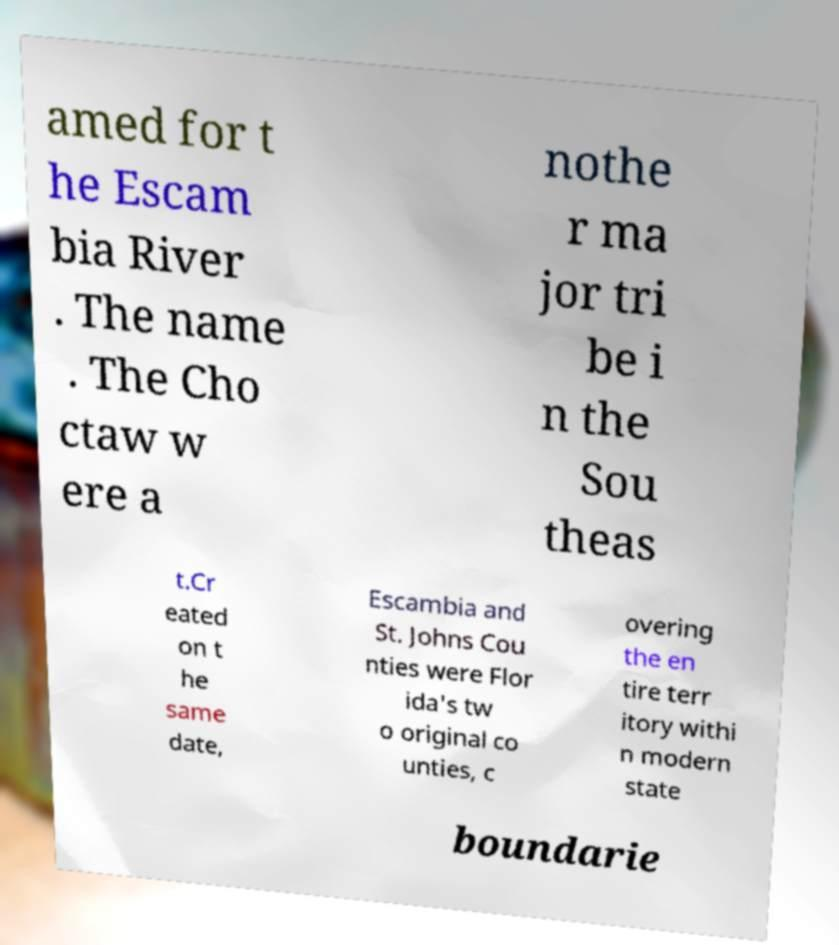Please read and relay the text visible in this image. What does it say? amed for t he Escam bia River . The name . The Cho ctaw w ere a nothe r ma jor tri be i n the Sou theas t.Cr eated on t he same date, Escambia and St. Johns Cou nties were Flor ida's tw o original co unties, c overing the en tire terr itory withi n modern state boundarie 